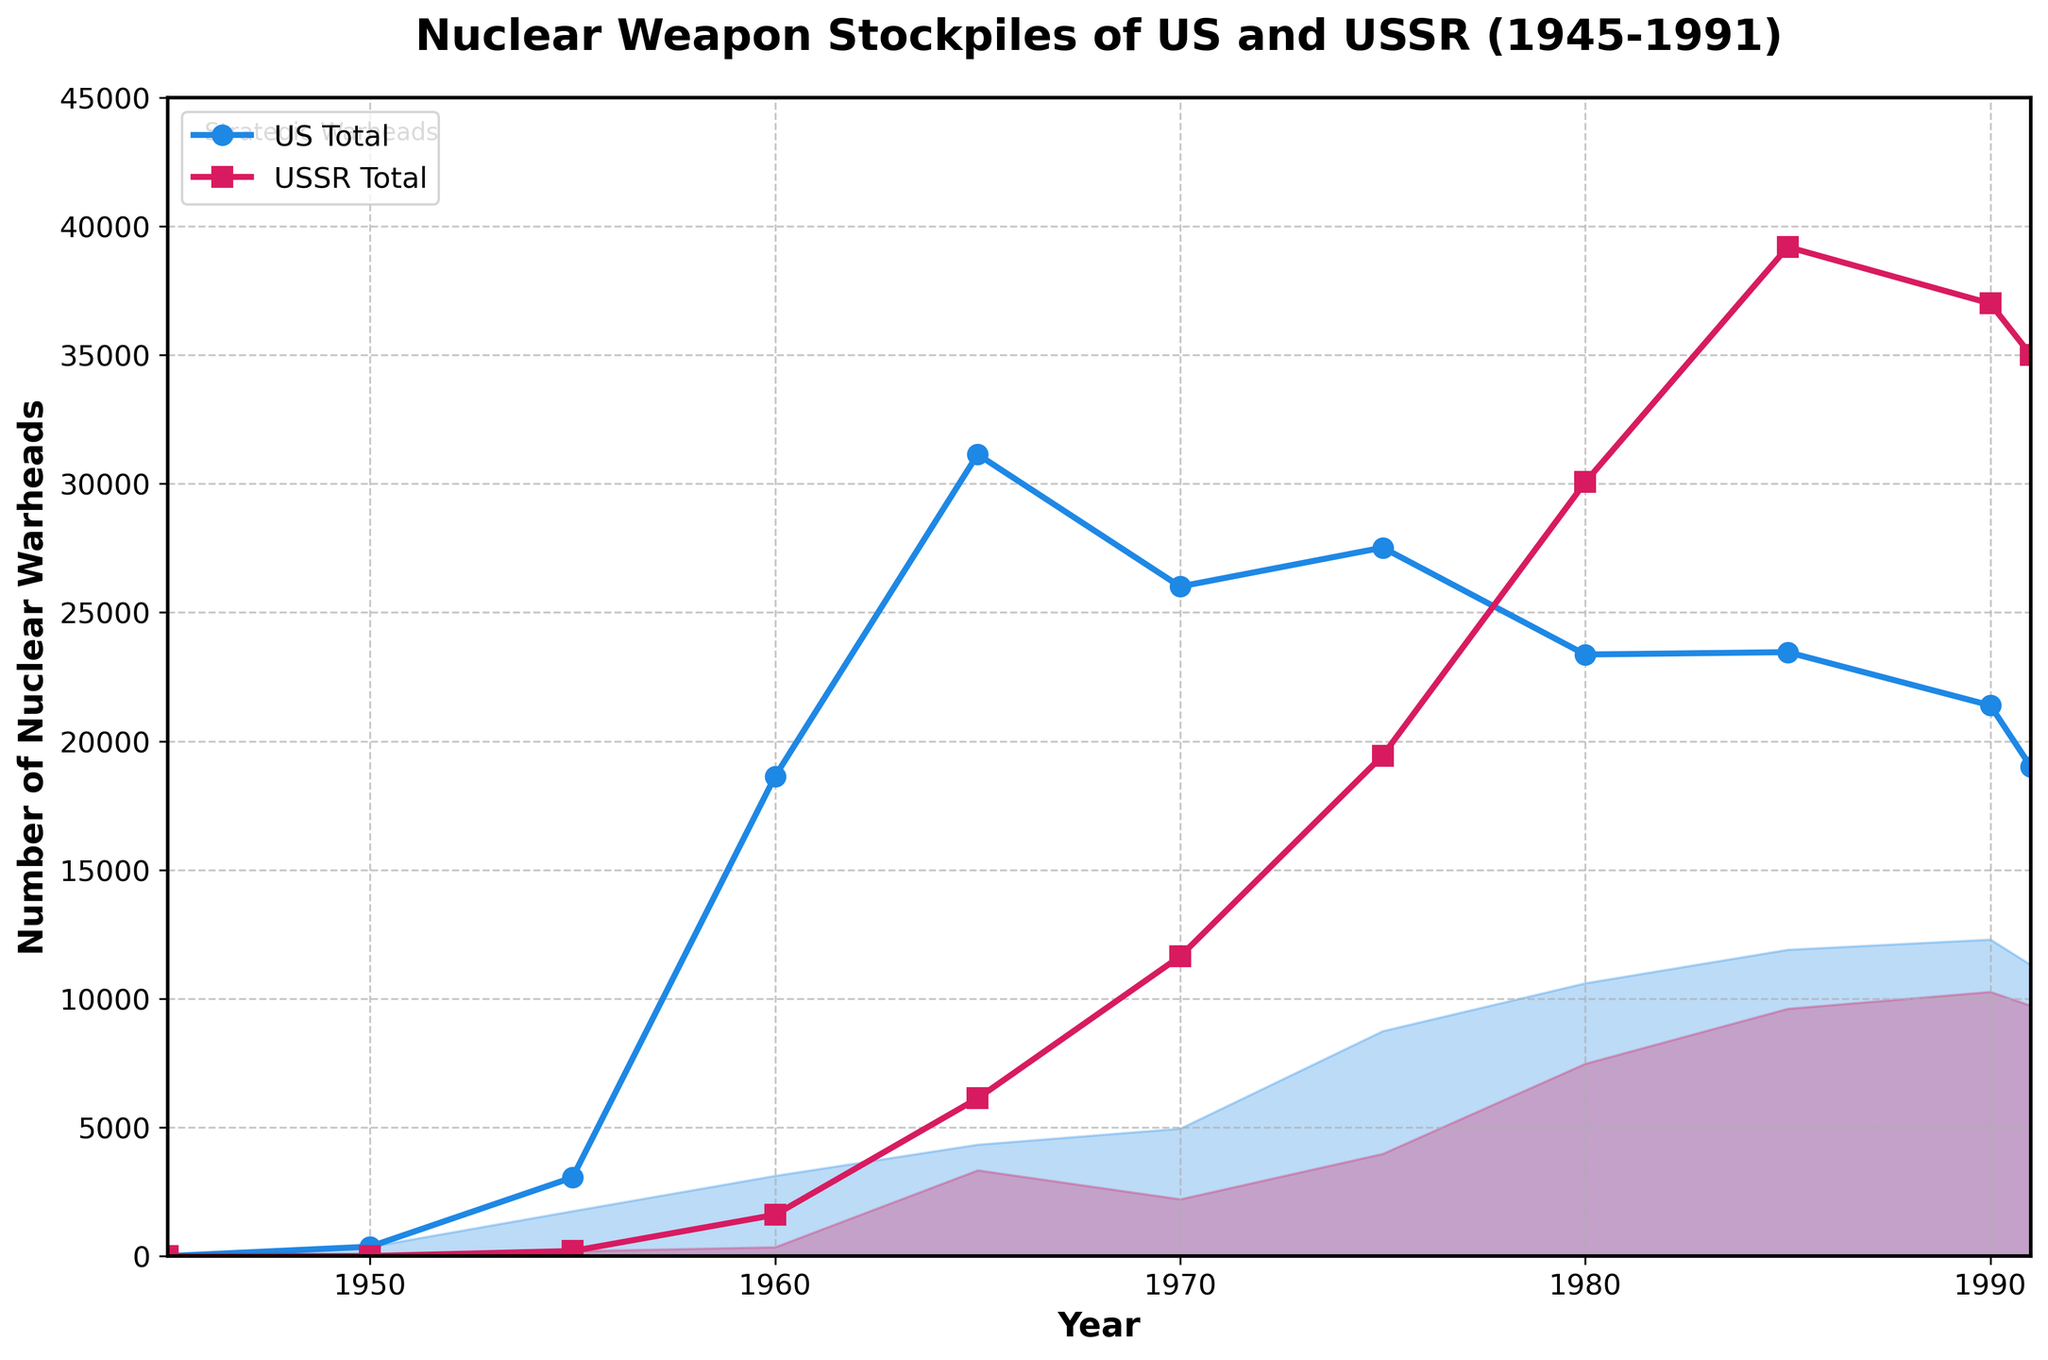What year had the highest number of US warheads in total? To find the year with the highest number of US warheads, look at the peaks of the blue line ('US Total') and identify the corresponding year. The highest point on the US Total line is around 1965.
Answer: 1965 How did the total number of US warheads compare to the total number of USSR warheads in 1980? Locate the total number of warheads for both the US and USSR in 1980 on their respective lines. The US had approximately 23,368 warheads, while the USSR had about 30,062 warheads. Compare the two numbers: 23,368 < 30,062.
Answer: USSR had more warheads What's the difference in the number of US tactical warheads between 1965 and 1985? To find the difference, subtract the number of US tactical warheads in 1965 (26,801) from the number in 1985 (11,550). 26,801 - 11,550 = 15,251.
Answer: 15,251 During which decade did the USSR see the largest increase in their total number of warheads? Evaluate the decade-by-decade increments for the USSR total warheads. The most significant increase happened between 1970 (11,643) and 1980 (30,062), an increase of 30,062 - 11,643 = 18,419.
Answer: 1970-1980 What is the combined number of strategic warheads for both the US and USSR in 1975? Sum the number of strategic warheads for the US (8,748) and USSR (3,981) in 1975. 8,748 + 3,981 = 12,729.
Answer: 12,729 How does the trend in US strategic warheads from 1970 to 1991 differ from the trend in USSR tactical warheads over the same period? Observe the separate trends in strategic and tactical warheads for the respective countries. US strategic warheads show a gradual increase with some fluctuations, while USSR tactical warheads portray a sharp rise from 1970 (9,427) to 1991 (25,266). The US had a steadier trend in strategic warheads, whereas the USSR had a sharper and more substantial increase in tactical warheads during this period.
Answer: US steady increase, USSR sharp rise What percentage of the total US warheads in 1990 were tactical warheads? Divide the number of US tactical warheads in 1990 (9,088) by the US total warheads that year (21,392) and multiply by 100 for the percentage. (9,088 / 21,392) * 100 ≈ 42.5%.
Answer: 42.5% When did the USSR tactical warheads surpass the US strategic warheads for the first time? Compare the respective lines for USSR Tactical and US Strategic warheads. The intersection first occurs around 1965 when USSR tactical warheads become greater than US strategic warheads.
Answer: 1965 